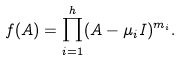<formula> <loc_0><loc_0><loc_500><loc_500>f ( A ) = \prod _ { i = 1 } ^ { h } ( A - \mu _ { i } I ) ^ { m _ { i } } .</formula> 